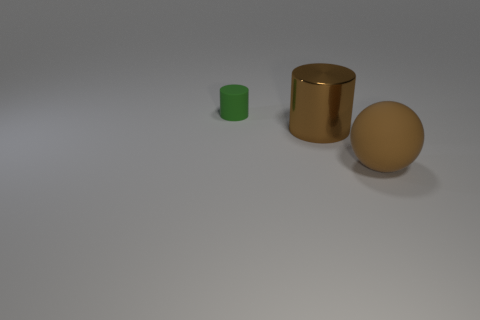Are there any other things that have the same size as the green cylinder?
Provide a succinct answer. No. How many other objects are there of the same color as the small rubber object?
Offer a terse response. 0. There is a cylinder in front of the tiny rubber cylinder; is its size the same as the green cylinder that is on the left side of the big matte object?
Your answer should be compact. No. How big is the cylinder that is on the left side of the big thing behind the large brown sphere?
Offer a terse response. Small. There is a thing that is in front of the green object and on the left side of the brown sphere; what material is it?
Give a very brief answer. Metal. The large ball is what color?
Keep it short and to the point. Brown. Are there any other things that have the same material as the small green cylinder?
Provide a succinct answer. Yes. What is the shape of the large brown object behind the big sphere?
Keep it short and to the point. Cylinder. There is a rubber thing that is on the right side of the matte thing that is left of the brown ball; is there a cylinder that is behind it?
Provide a succinct answer. Yes. Are there any other things that have the same shape as the green thing?
Keep it short and to the point. Yes. 